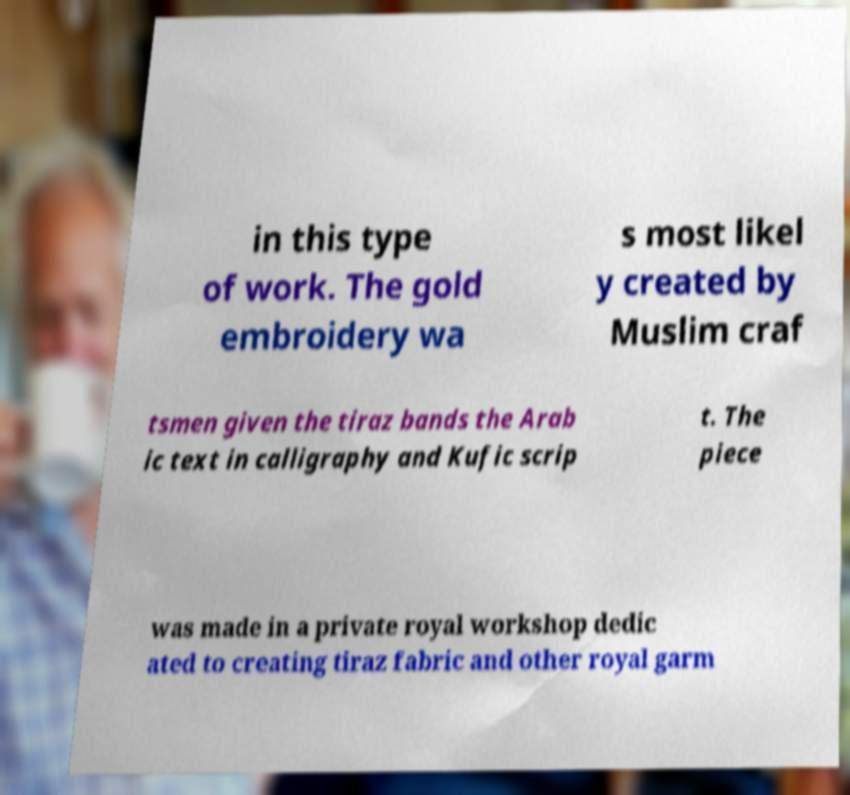Please identify and transcribe the text found in this image. in this type of work. The gold embroidery wa s most likel y created by Muslim craf tsmen given the tiraz bands the Arab ic text in calligraphy and Kufic scrip t. The piece was made in a private royal workshop dedic ated to creating tiraz fabric and other royal garm 